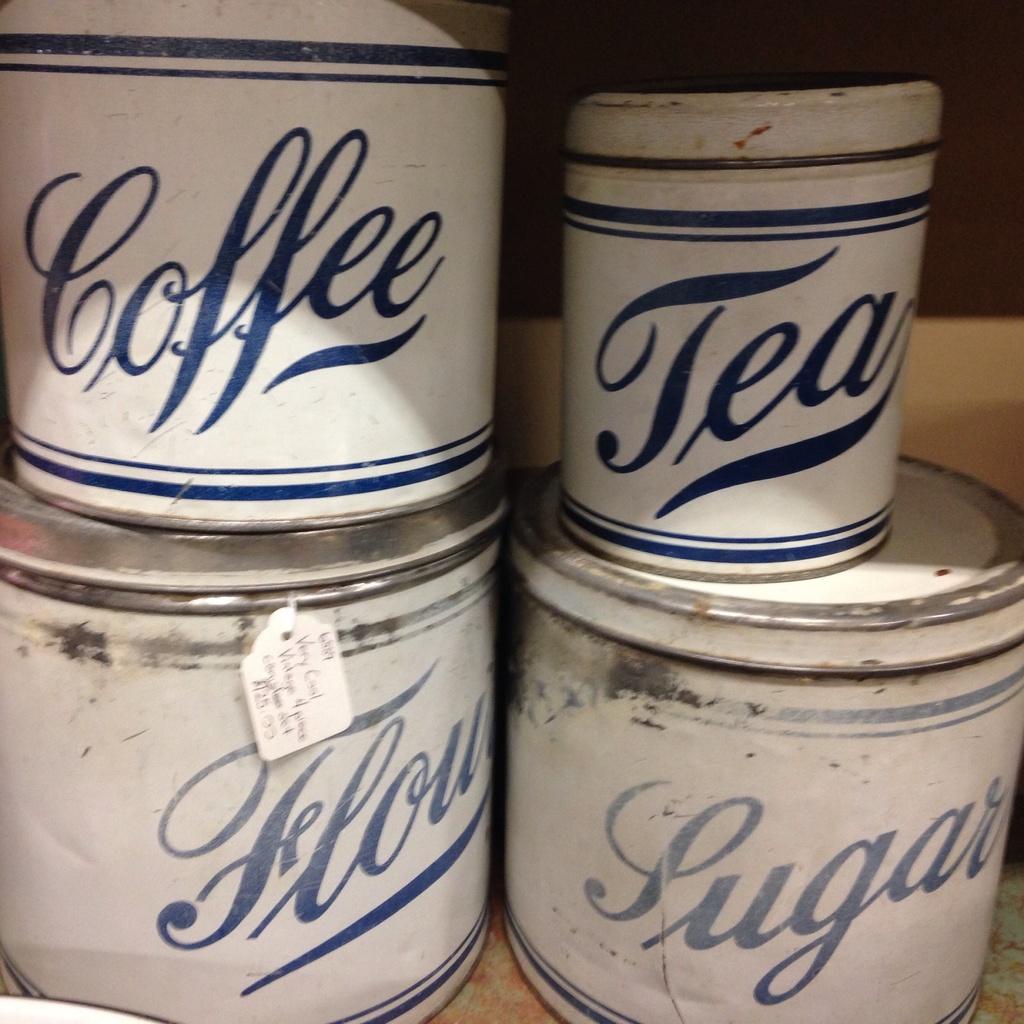What is kept in the smallest canister?
Ensure brevity in your answer.  Tea. 